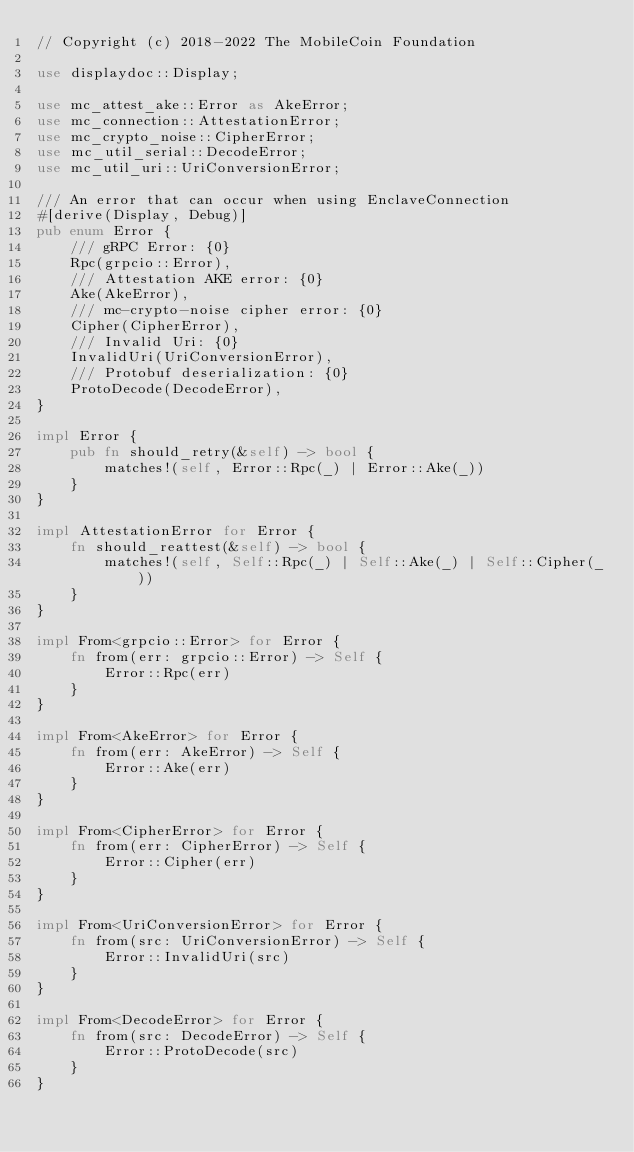Convert code to text. <code><loc_0><loc_0><loc_500><loc_500><_Rust_>// Copyright (c) 2018-2022 The MobileCoin Foundation

use displaydoc::Display;

use mc_attest_ake::Error as AkeError;
use mc_connection::AttestationError;
use mc_crypto_noise::CipherError;
use mc_util_serial::DecodeError;
use mc_util_uri::UriConversionError;

/// An error that can occur when using EnclaveConnection
#[derive(Display, Debug)]
pub enum Error {
    /// gRPC Error: {0}
    Rpc(grpcio::Error),
    /// Attestation AKE error: {0}
    Ake(AkeError),
    /// mc-crypto-noise cipher error: {0}
    Cipher(CipherError),
    /// Invalid Uri: {0}
    InvalidUri(UriConversionError),
    /// Protobuf deserialization: {0}
    ProtoDecode(DecodeError),
}

impl Error {
    pub fn should_retry(&self) -> bool {
        matches!(self, Error::Rpc(_) | Error::Ake(_))
    }
}

impl AttestationError for Error {
    fn should_reattest(&self) -> bool {
        matches!(self, Self::Rpc(_) | Self::Ake(_) | Self::Cipher(_))
    }
}

impl From<grpcio::Error> for Error {
    fn from(err: grpcio::Error) -> Self {
        Error::Rpc(err)
    }
}

impl From<AkeError> for Error {
    fn from(err: AkeError) -> Self {
        Error::Ake(err)
    }
}

impl From<CipherError> for Error {
    fn from(err: CipherError) -> Self {
        Error::Cipher(err)
    }
}

impl From<UriConversionError> for Error {
    fn from(src: UriConversionError) -> Self {
        Error::InvalidUri(src)
    }
}

impl From<DecodeError> for Error {
    fn from(src: DecodeError) -> Self {
        Error::ProtoDecode(src)
    }
}
</code> 